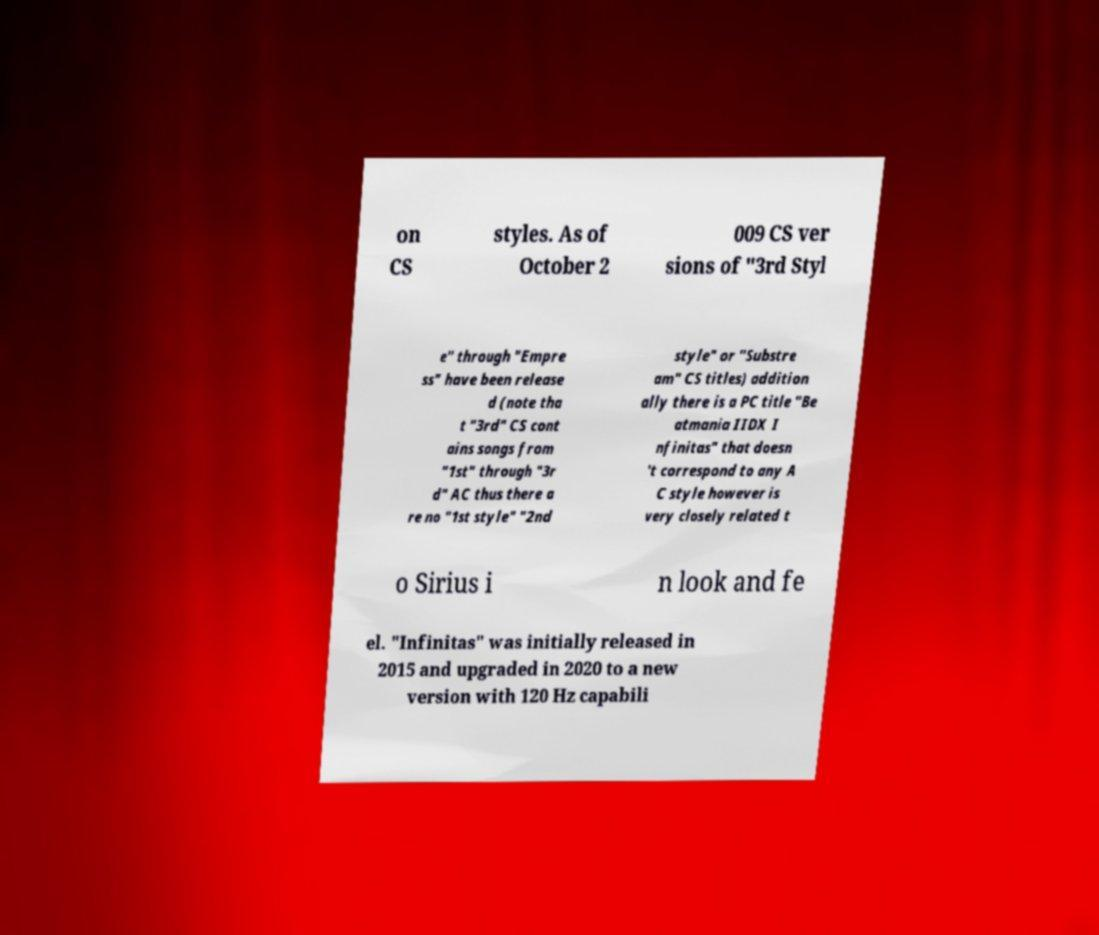Could you assist in decoding the text presented in this image and type it out clearly? on CS styles. As of October 2 009 CS ver sions of "3rd Styl e" through "Empre ss" have been release d (note tha t "3rd" CS cont ains songs from "1st" through "3r d" AC thus there a re no "1st style" "2nd style" or "Substre am" CS titles) addition ally there is a PC title "Be atmania IIDX I nfinitas" that doesn 't correspond to any A C style however is very closely related t o Sirius i n look and fe el. "Infinitas" was initially released in 2015 and upgraded in 2020 to a new version with 120 Hz capabili 